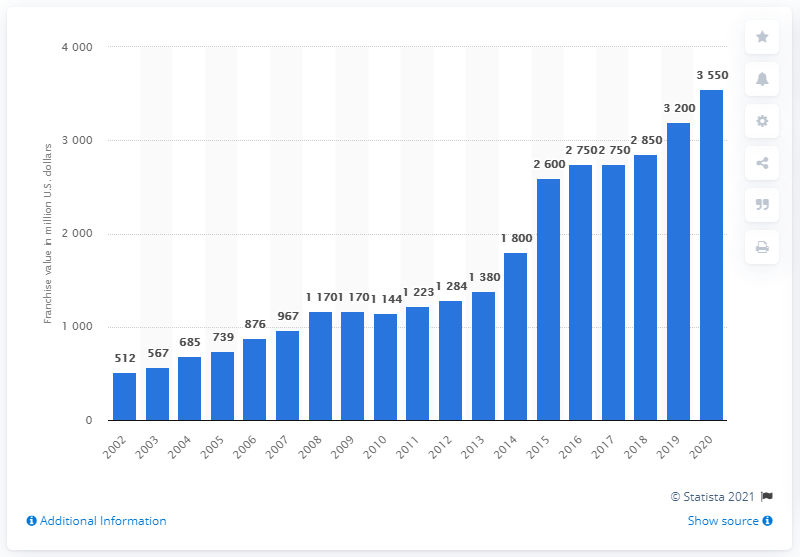Indicate a few pertinent items in this graphic. The franchise value of the New York Jets in 2020 was 3,550. 